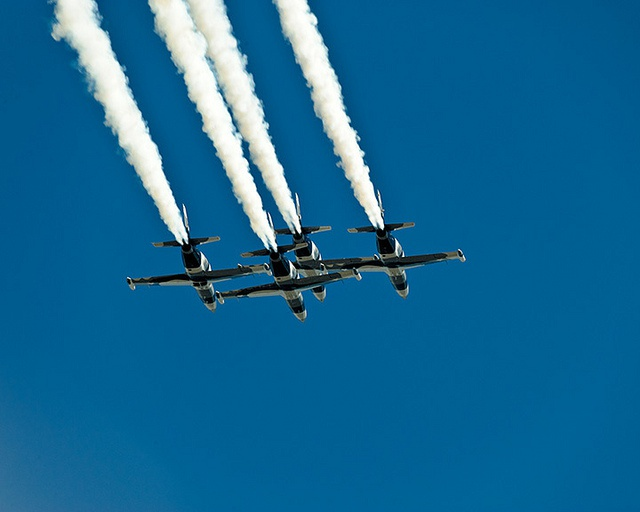Describe the objects in this image and their specific colors. I can see airplane in blue, black, and gray tones, airplane in blue, black, and gray tones, airplane in blue, black, gray, and darkblue tones, and airplane in blue, black, gray, and darkgray tones in this image. 